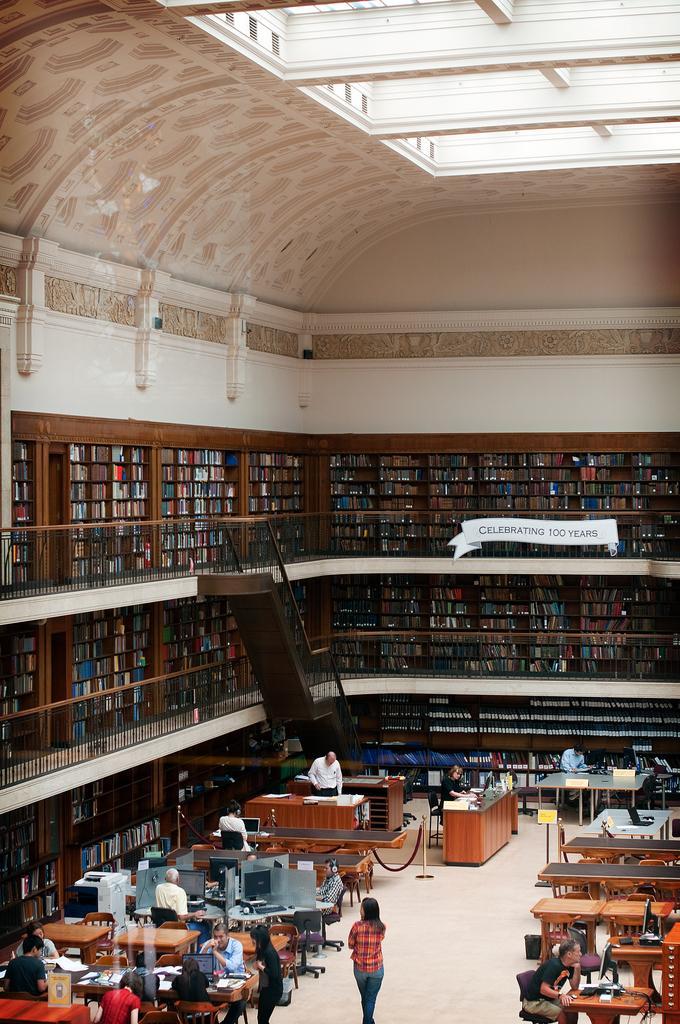In one or two sentences, can you explain what this image depicts? In this image we can see a building. In the building there are books arranged in the cupboards, railings, staircases, persons standing on the floor and sitting on the chairs, printers, desktops, tables, barrier poles and information boards. 